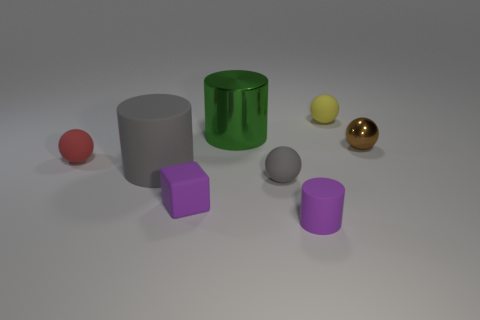Add 1 small gray things. How many objects exist? 9 Subtract all blocks. How many objects are left? 7 Subtract 0 green spheres. How many objects are left? 8 Subtract all small purple rubber objects. Subtract all matte cubes. How many objects are left? 5 Add 3 small brown spheres. How many small brown spheres are left? 4 Add 2 big metallic cylinders. How many big metallic cylinders exist? 3 